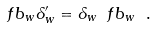<formula> <loc_0><loc_0><loc_500><loc_500>\ f b _ { w } \delta ^ { \prime } _ { w } = \delta _ { w } \ f b _ { w } \ .</formula> 